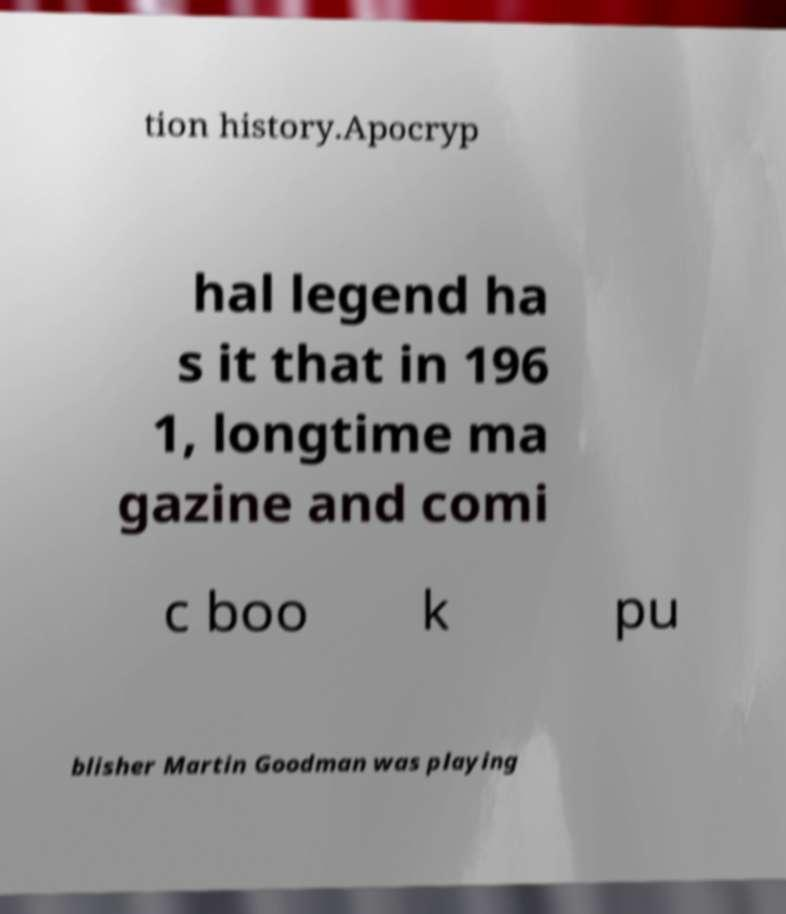For documentation purposes, I need the text within this image transcribed. Could you provide that? tion history.Apocryp hal legend ha s it that in 196 1, longtime ma gazine and comi c boo k pu blisher Martin Goodman was playing 